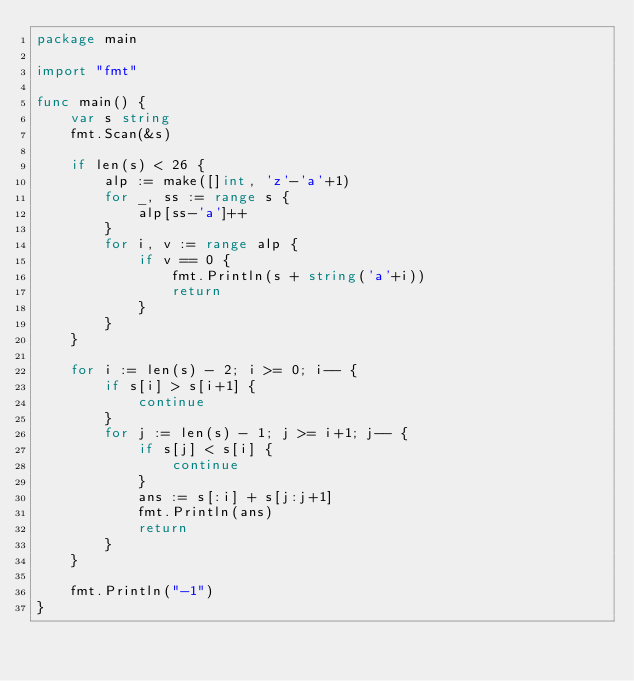<code> <loc_0><loc_0><loc_500><loc_500><_Go_>package main

import "fmt"

func main() {
	var s string
	fmt.Scan(&s)

	if len(s) < 26 {
		alp := make([]int, 'z'-'a'+1)
		for _, ss := range s {
			alp[ss-'a']++
		}
		for i, v := range alp {
			if v == 0 {
				fmt.Println(s + string('a'+i))
				return
			}
		}
	}

	for i := len(s) - 2; i >= 0; i-- {
		if s[i] > s[i+1] {
			continue
		}
		for j := len(s) - 1; j >= i+1; j-- {
			if s[j] < s[i] {
				continue
			}
			ans := s[:i] + s[j:j+1]
			fmt.Println(ans)
			return
		}
	}

	fmt.Println("-1")
}
</code> 